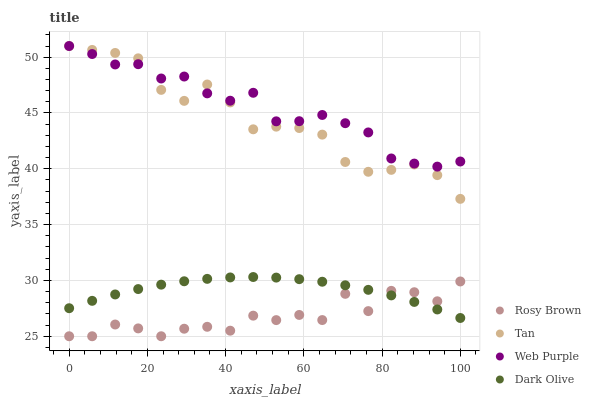Does Rosy Brown have the minimum area under the curve?
Answer yes or no. Yes. Does Web Purple have the maximum area under the curve?
Answer yes or no. Yes. Does Tan have the minimum area under the curve?
Answer yes or no. No. Does Tan have the maximum area under the curve?
Answer yes or no. No. Is Dark Olive the smoothest?
Answer yes or no. Yes. Is Rosy Brown the roughest?
Answer yes or no. Yes. Is Tan the smoothest?
Answer yes or no. No. Is Tan the roughest?
Answer yes or no. No. Does Rosy Brown have the lowest value?
Answer yes or no. Yes. Does Tan have the lowest value?
Answer yes or no. No. Does Web Purple have the highest value?
Answer yes or no. Yes. Does Rosy Brown have the highest value?
Answer yes or no. No. Is Rosy Brown less than Tan?
Answer yes or no. Yes. Is Tan greater than Dark Olive?
Answer yes or no. Yes. Does Rosy Brown intersect Dark Olive?
Answer yes or no. Yes. Is Rosy Brown less than Dark Olive?
Answer yes or no. No. Is Rosy Brown greater than Dark Olive?
Answer yes or no. No. Does Rosy Brown intersect Tan?
Answer yes or no. No. 